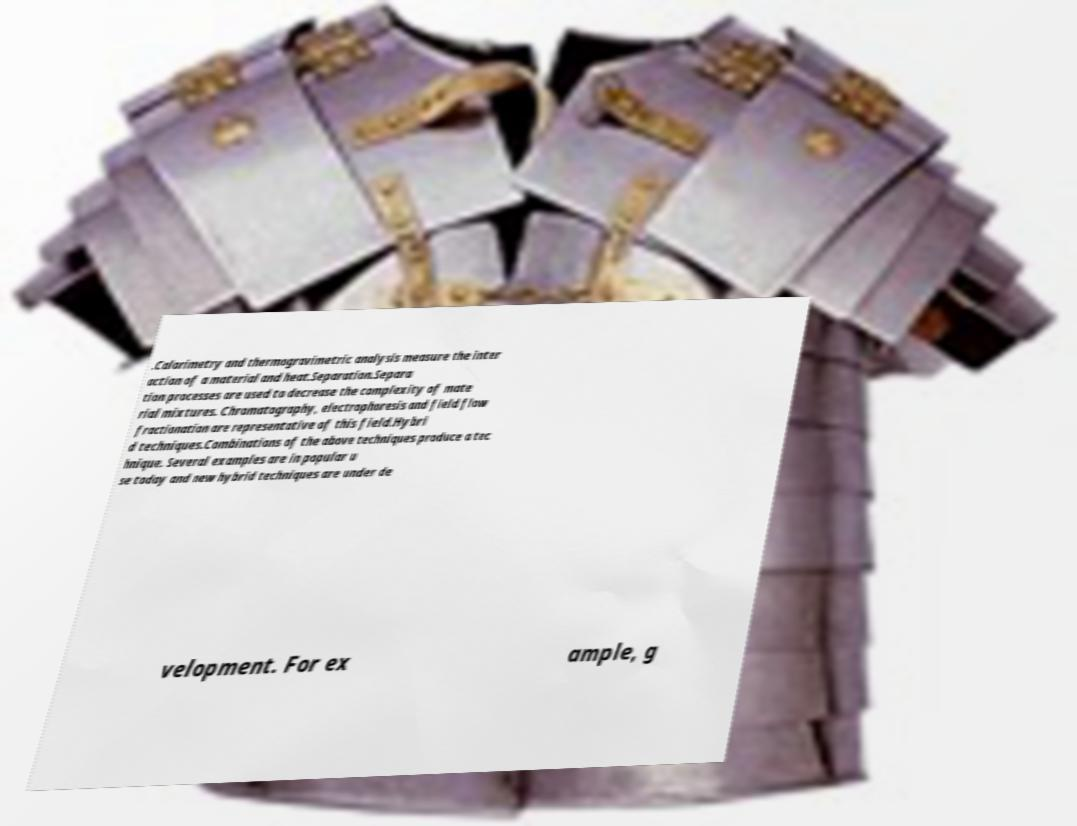I need the written content from this picture converted into text. Can you do that? .Calorimetry and thermogravimetric analysis measure the inter action of a material and heat.Separation.Separa tion processes are used to decrease the complexity of mate rial mixtures. Chromatography, electrophoresis and field flow fractionation are representative of this field.Hybri d techniques.Combinations of the above techniques produce a tec hnique. Several examples are in popular u se today and new hybrid techniques are under de velopment. For ex ample, g 